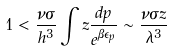Convert formula to latex. <formula><loc_0><loc_0><loc_500><loc_500>1 < \frac { \nu \sigma } { h ^ { 3 } } \int z \frac { d p } { e ^ { \beta \epsilon _ { p } } } \sim \frac { \nu \sigma z } { \lambda ^ { 3 } }</formula> 